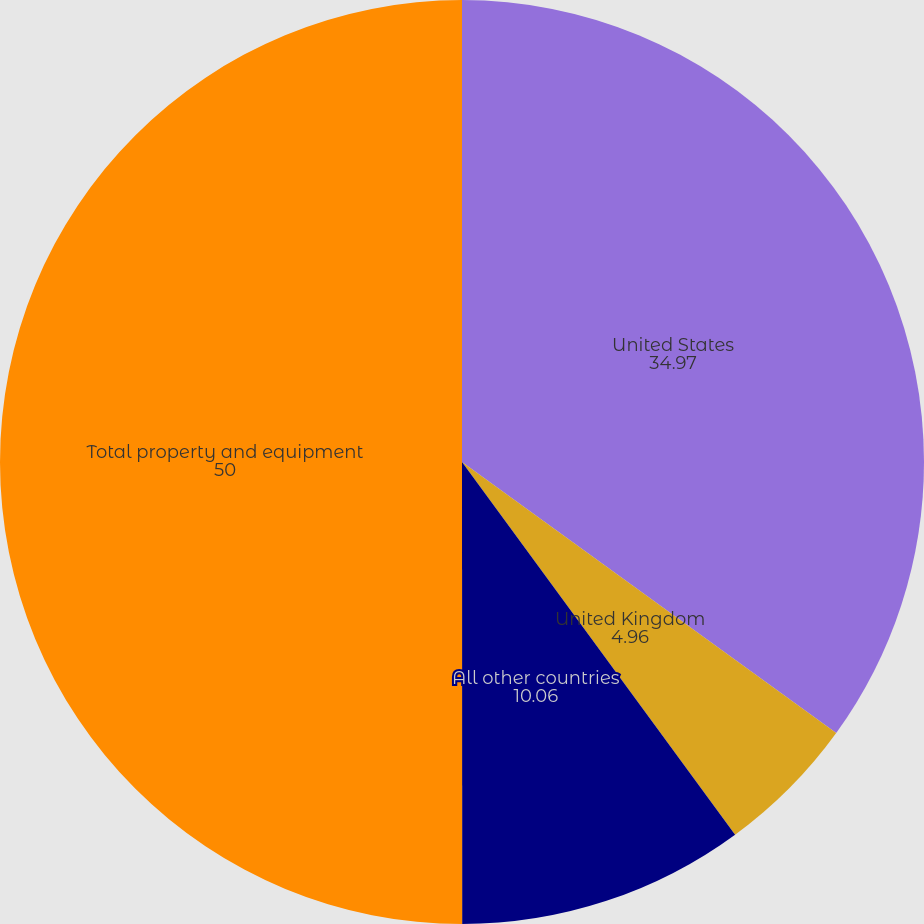Convert chart to OTSL. <chart><loc_0><loc_0><loc_500><loc_500><pie_chart><fcel>United States<fcel>United Kingdom<fcel>All other countries<fcel>Total property and equipment<nl><fcel>34.97%<fcel>4.96%<fcel>10.06%<fcel>50.0%<nl></chart> 